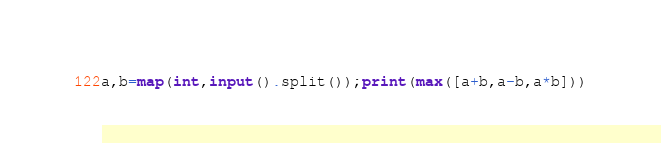Convert code to text. <code><loc_0><loc_0><loc_500><loc_500><_Python_>a,b=map(int,input().split());print(max([a+b,a-b,a*b]))</code> 